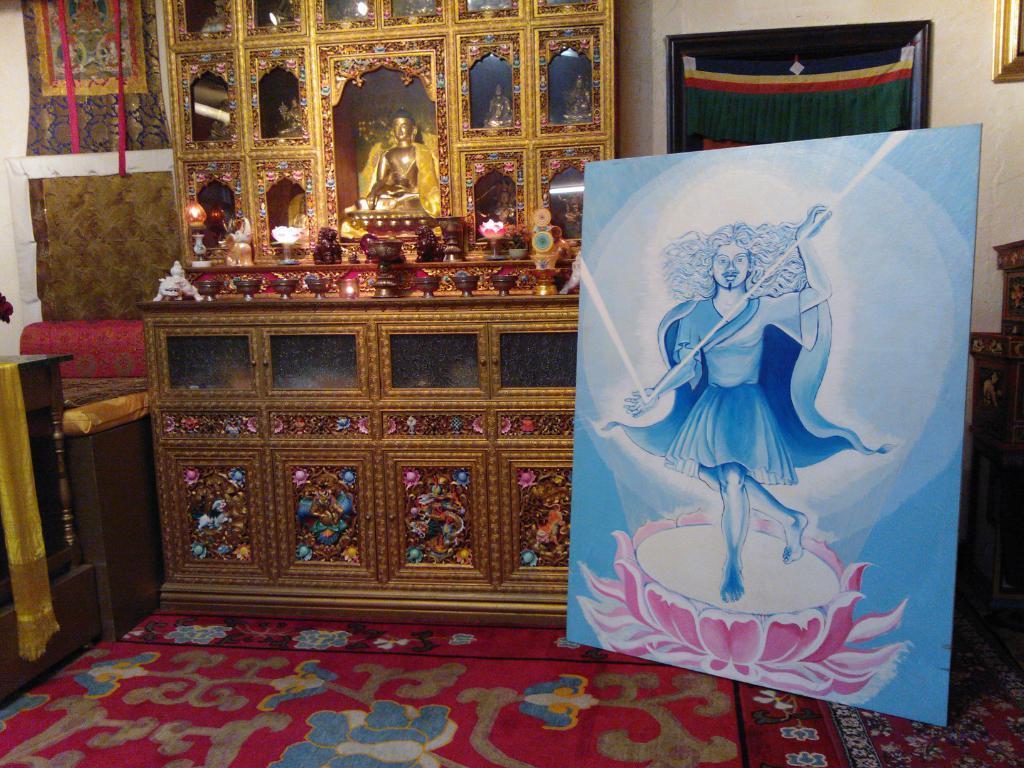Describe this image in one or two sentences. On the right side of the image we can see a painting of a person, beside it there is a sculpture and some objects are placed on it, on the left side of the image there is a sofa and there is a painting on the wall. 